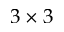Convert formula to latex. <formula><loc_0><loc_0><loc_500><loc_500>3 \times 3</formula> 